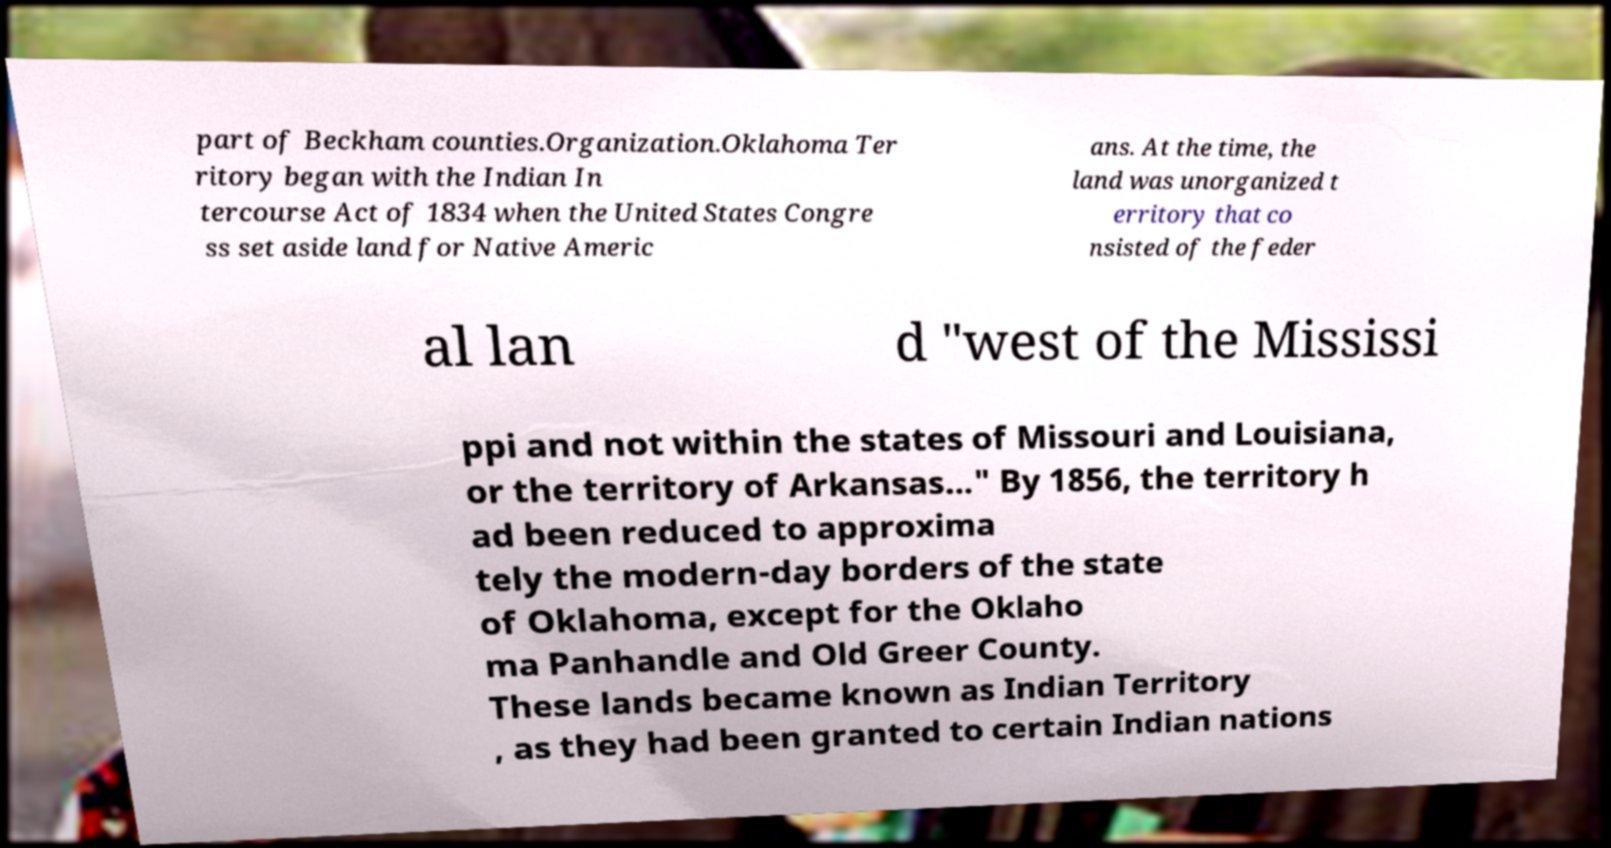Can you accurately transcribe the text from the provided image for me? part of Beckham counties.Organization.Oklahoma Ter ritory began with the Indian In tercourse Act of 1834 when the United States Congre ss set aside land for Native Americ ans. At the time, the land was unorganized t erritory that co nsisted of the feder al lan d "west of the Mississi ppi and not within the states of Missouri and Louisiana, or the territory of Arkansas..." By 1856, the territory h ad been reduced to approxima tely the modern-day borders of the state of Oklahoma, except for the Oklaho ma Panhandle and Old Greer County. These lands became known as Indian Territory , as they had been granted to certain Indian nations 